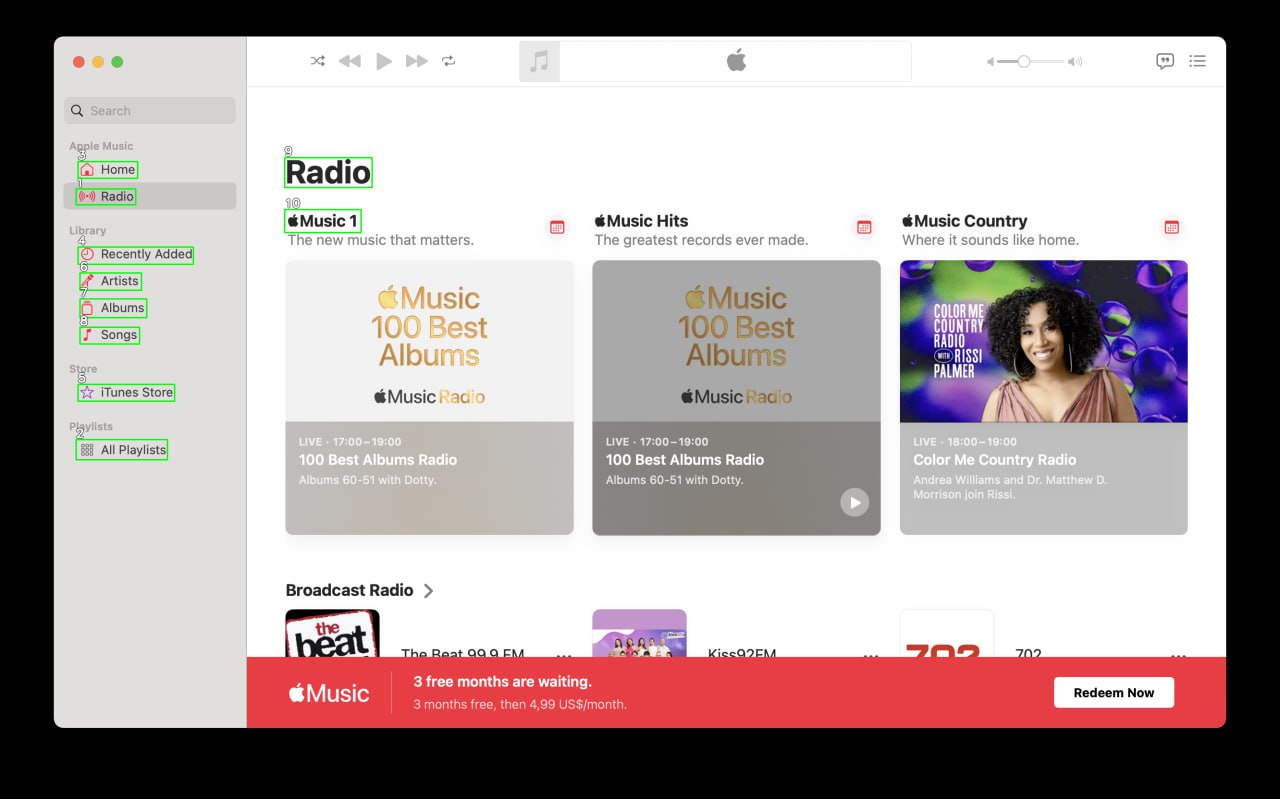Your task is to analyze the screenshot of the {app_name} on MacOS.  The screenshot is segmented with bounding boxes, each labeled with a number. The labels are always white numbers with a black outline. Number is always situated in the top left corner above the box. Describe each of the boxes numbered 1 to 10. For each identified element, provide a description that correlates with its functionality. If the element type is AXImage, write an alternative text describing the image content. Include text from the box if it is presented. Provide the output in the JSON format. ```json
{
  "1": {
    "type": "AXStaticText",
    "label": "Music"
  },
  "2": {
    "type": "AXButton",
    "label": "Home"
  },
  "3": {
    "type": "AXButton",
    "label": "Library"
  },
  "4": {
    "type": "AXButton",
    "label": "For You"
  },
  "5": {
    "type": "AXButton",
    "label": "Browse"
  },
  "6": {
    "type": "AXButton",
    "label": "Radio"
  },
  "7": {
    "type": "AXButton",
    "label": "Search"
  },
  "8": {
    "type": "AXImage",
    "label": "Music 1",
    "alternativeText": "A stylized drawing of a speaker playing music."
  },
  "9": {
    "type": "AXStaticText",
    "label": "Music 1"
  },
  "10": {
    "type": "AXStaticText",
    "label": "The new music that matters."
  }
}
``` 